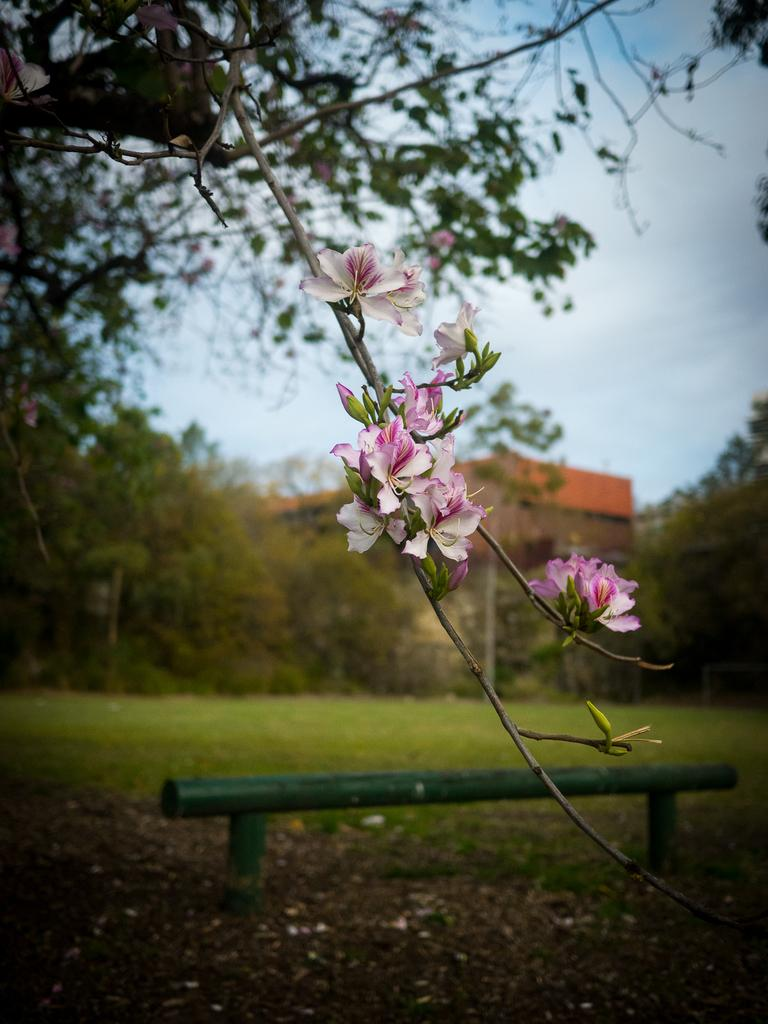What is on the tree branch in the image? There are flowers on a tree branch in the image. What can be seen in the background of the image? There are trees and a house in the background of the image. What is the condition of the sky in the image? The sky is cloudy in the image. What is the rod visible in the image used for? The purpose of the rod in the image is not specified, so it cannot be determined from the image alone. Can you tell me how many goldfish are swimming in the kettle in the image? There are no goldfish or kettle present in the image. What news story is being discussed by the flowers on the tree branch? The flowers on the tree branch are not discussing any news stories, as they are inanimate objects and cannot communicate. 